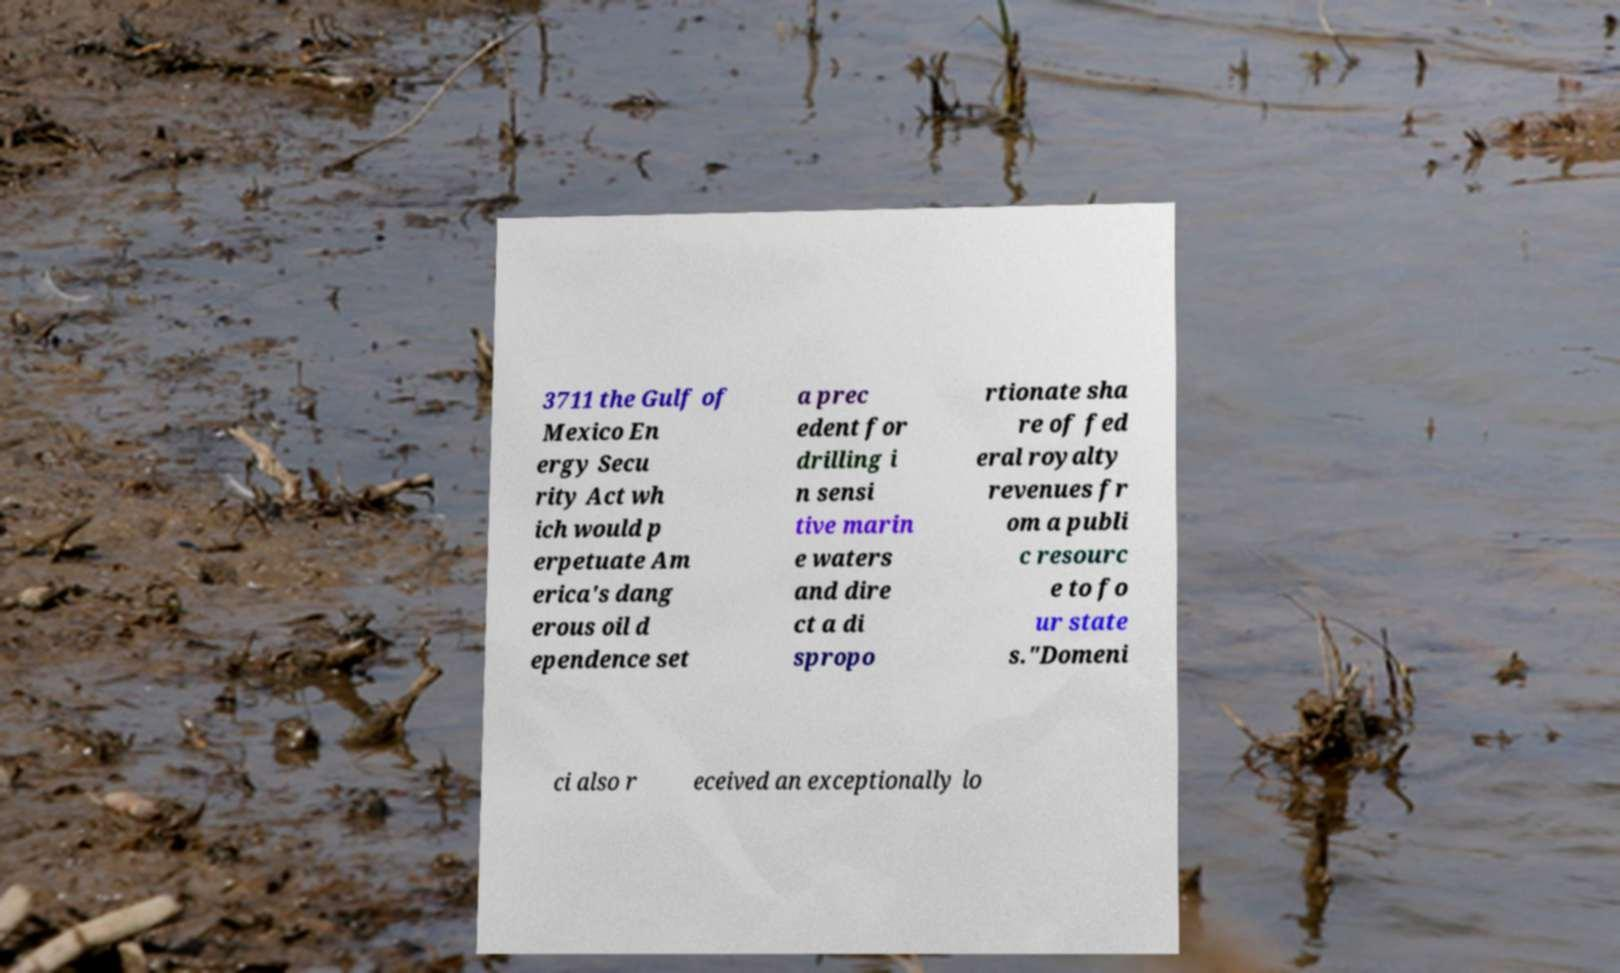I need the written content from this picture converted into text. Can you do that? 3711 the Gulf of Mexico En ergy Secu rity Act wh ich would p erpetuate Am erica's dang erous oil d ependence set a prec edent for drilling i n sensi tive marin e waters and dire ct a di spropo rtionate sha re of fed eral royalty revenues fr om a publi c resourc e to fo ur state s."Domeni ci also r eceived an exceptionally lo 